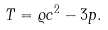<formula> <loc_0><loc_0><loc_500><loc_500>T = \varrho c ^ { 2 } - 3 p .</formula> 